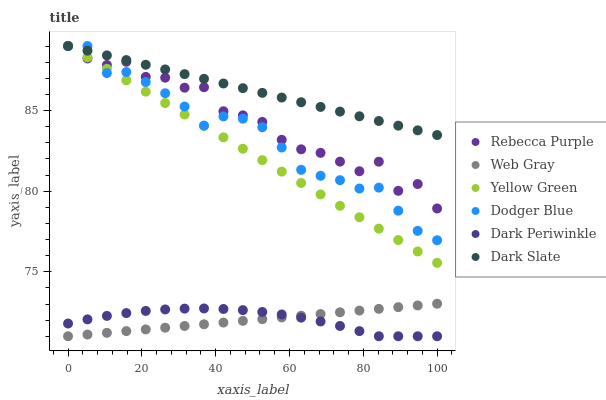Does Web Gray have the minimum area under the curve?
Answer yes or no. Yes. Does Dark Slate have the maximum area under the curve?
Answer yes or no. Yes. Does Yellow Green have the minimum area under the curve?
Answer yes or no. No. Does Yellow Green have the maximum area under the curve?
Answer yes or no. No. Is Web Gray the smoothest?
Answer yes or no. Yes. Is Rebecca Purple the roughest?
Answer yes or no. Yes. Is Yellow Green the smoothest?
Answer yes or no. No. Is Yellow Green the roughest?
Answer yes or no. No. Does Web Gray have the lowest value?
Answer yes or no. Yes. Does Yellow Green have the lowest value?
Answer yes or no. No. Does Rebecca Purple have the highest value?
Answer yes or no. Yes. Does Dark Periwinkle have the highest value?
Answer yes or no. No. Is Web Gray less than Dark Slate?
Answer yes or no. Yes. Is Rebecca Purple greater than Dark Periwinkle?
Answer yes or no. Yes. Does Dark Slate intersect Yellow Green?
Answer yes or no. Yes. Is Dark Slate less than Yellow Green?
Answer yes or no. No. Is Dark Slate greater than Yellow Green?
Answer yes or no. No. Does Web Gray intersect Dark Slate?
Answer yes or no. No. 